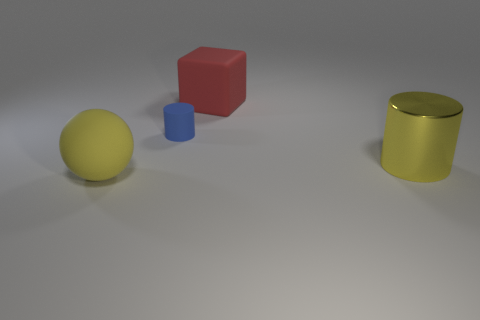What is the material of the ball that is the same color as the shiny object?
Your answer should be very brief. Rubber. How many cylinders are large yellow things or matte objects?
Provide a short and direct response. 2. What size is the matte object that is the same color as the large shiny cylinder?
Your answer should be compact. Large. Is the number of small cylinders in front of the yellow metallic thing less than the number of gray spheres?
Give a very brief answer. No. There is a object that is both in front of the red object and behind the big yellow metal cylinder; what color is it?
Your response must be concise. Blue. What number of other things are there of the same shape as the small blue matte object?
Provide a short and direct response. 1. Are there fewer tiny blue objects in front of the tiny blue rubber object than tiny blue objects that are in front of the yellow rubber sphere?
Your response must be concise. No. Are the big yellow sphere and the big yellow thing that is to the right of the rubber block made of the same material?
Provide a short and direct response. No. Is there anything else that is made of the same material as the sphere?
Offer a terse response. Yes. Are there more big purple metal cubes than rubber cubes?
Provide a short and direct response. No. 